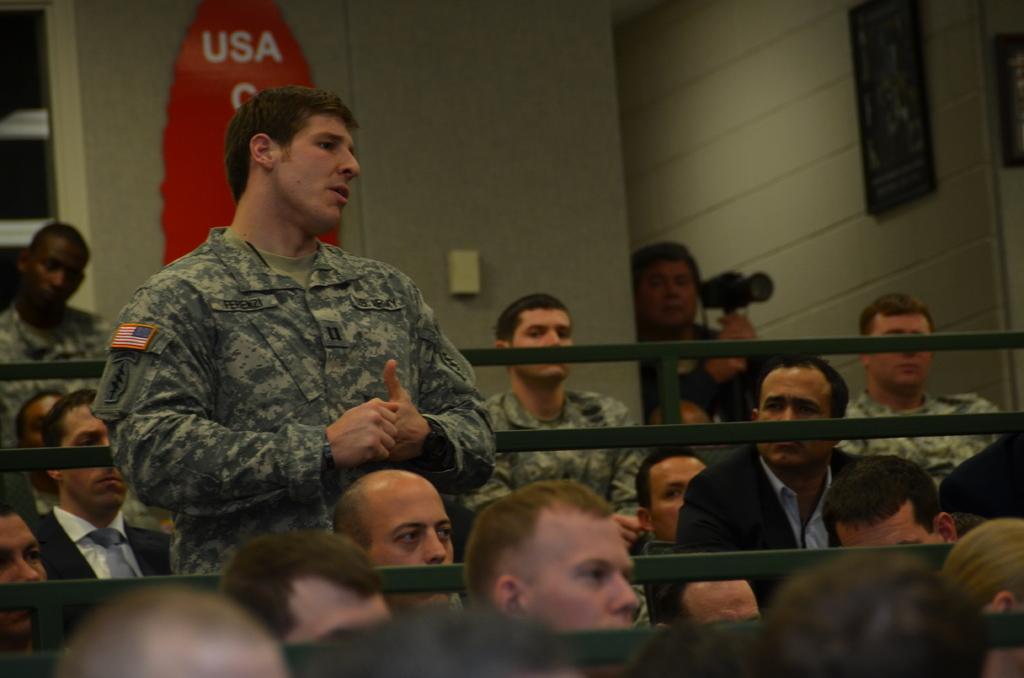Could you give a brief overview of what you see in this image? In this image there is an army personnel standing, around the person there are few other people sitting on the chairs and there are metal rod fences, behind them there are photo frames and some other objects on the wall. 